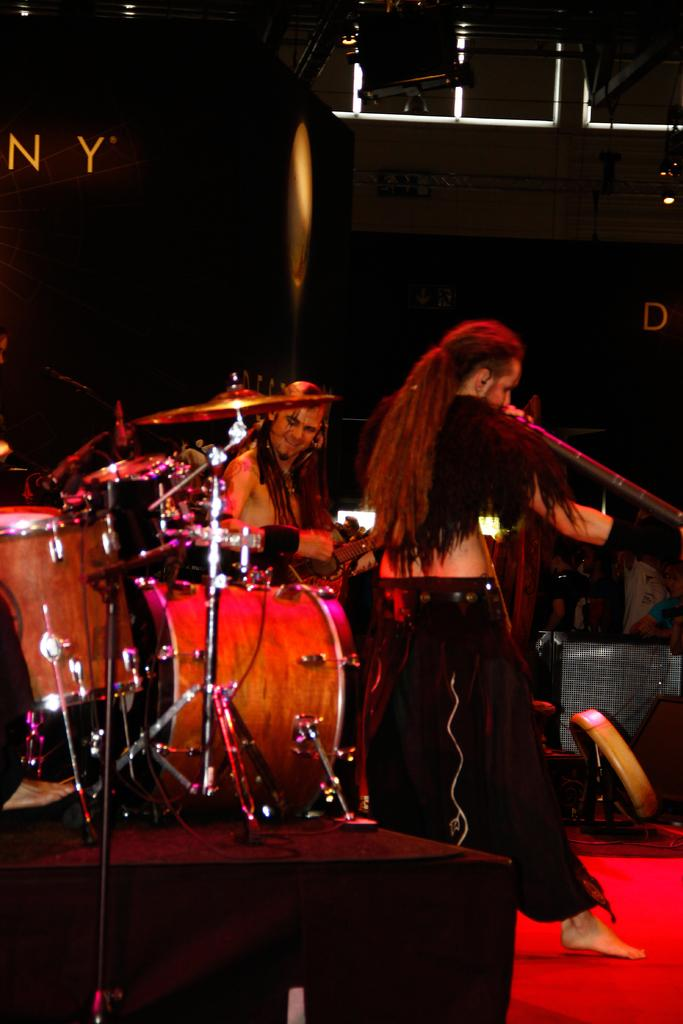How many people are in the image? There are two guys in the image. What are the guys doing in the image? The guys are playing musical instruments. What can be seen in the background of the image? There is a black curtain in the background of the image. What type of thing is being distributed by the guys in the image? There is no indication in the image that the guys are distributing anything; they are playing musical instruments. How many legs does each guy have in the image? The number of legs each guy has cannot be determined from the image, as only their upper bodies and instruments are visible. 